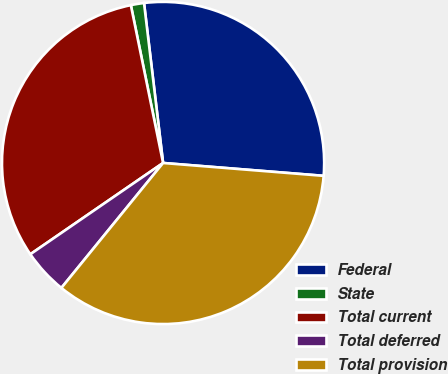Convert chart. <chart><loc_0><loc_0><loc_500><loc_500><pie_chart><fcel>Federal<fcel>State<fcel>Total current<fcel>Total deferred<fcel>Total provision<nl><fcel>28.16%<fcel>1.32%<fcel>31.38%<fcel>4.54%<fcel>34.6%<nl></chart> 